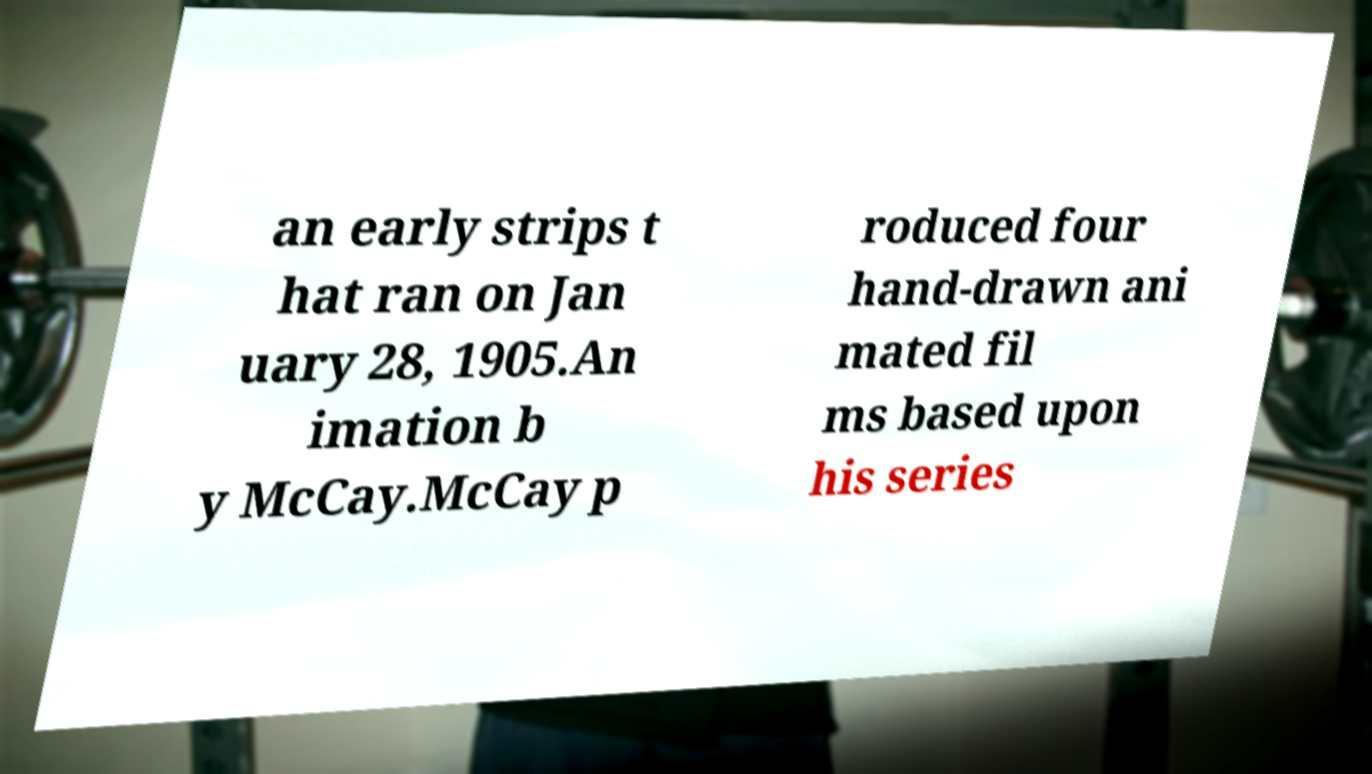Can you accurately transcribe the text from the provided image for me? an early strips t hat ran on Jan uary 28, 1905.An imation b y McCay.McCay p roduced four hand-drawn ani mated fil ms based upon his series 